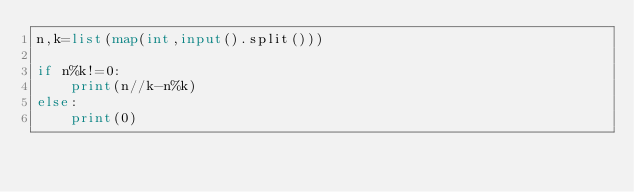Convert code to text. <code><loc_0><loc_0><loc_500><loc_500><_Python_>n,k=list(map(int,input().split()))

if n%k!=0:
    print(n//k-n%k)
else:
    print(0)</code> 